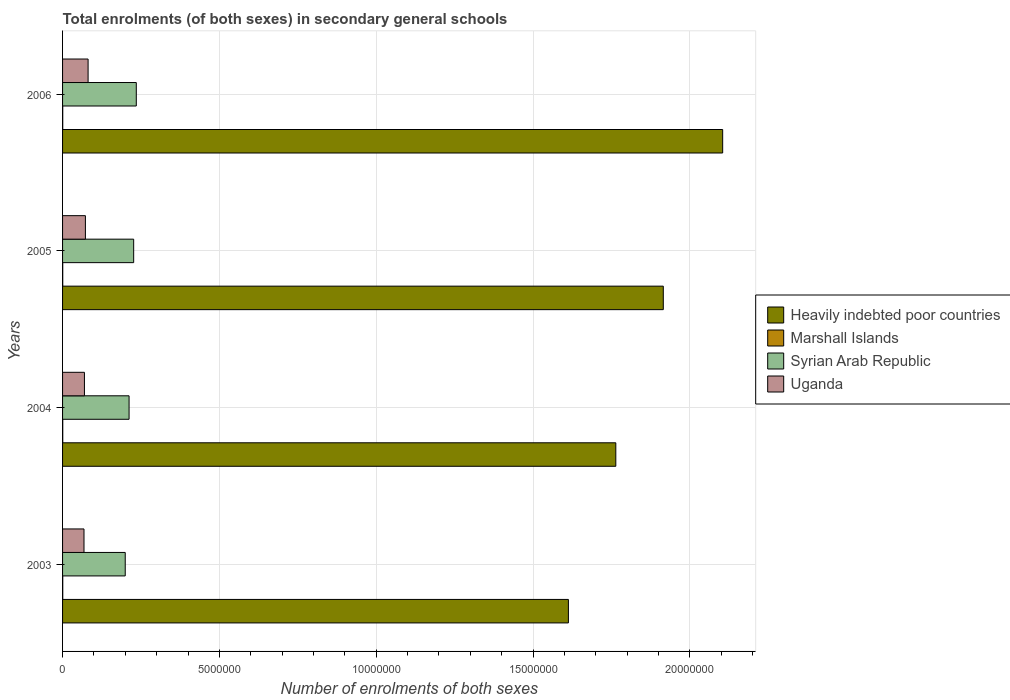Are the number of bars on each tick of the Y-axis equal?
Provide a short and direct response. Yes. How many bars are there on the 2nd tick from the top?
Give a very brief answer. 4. How many bars are there on the 1st tick from the bottom?
Make the answer very short. 4. What is the number of enrolments in secondary schools in Uganda in 2003?
Provide a succinct answer. 6.84e+05. Across all years, what is the maximum number of enrolments in secondary schools in Uganda?
Your response must be concise. 8.14e+05. Across all years, what is the minimum number of enrolments in secondary schools in Marshall Islands?
Your response must be concise. 5260. In which year was the number of enrolments in secondary schools in Syrian Arab Republic minimum?
Your answer should be compact. 2003. What is the total number of enrolments in secondary schools in Marshall Islands in the graph?
Give a very brief answer. 2.23e+04. What is the difference between the number of enrolments in secondary schools in Marshall Islands in 2004 and that in 2006?
Provide a succinct answer. 477. What is the difference between the number of enrolments in secondary schools in Uganda in 2006 and the number of enrolments in secondary schools in Marshall Islands in 2005?
Your answer should be very brief. 8.09e+05. What is the average number of enrolments in secondary schools in Uganda per year?
Your answer should be compact. 7.31e+05. In the year 2005, what is the difference between the number of enrolments in secondary schools in Marshall Islands and number of enrolments in secondary schools in Uganda?
Give a very brief answer. -7.23e+05. In how many years, is the number of enrolments in secondary schools in Uganda greater than 20000000 ?
Provide a short and direct response. 0. What is the ratio of the number of enrolments in secondary schools in Marshall Islands in 2004 to that in 2006?
Provide a succinct answer. 1.09. Is the number of enrolments in secondary schools in Syrian Arab Republic in 2003 less than that in 2005?
Give a very brief answer. Yes. Is the difference between the number of enrolments in secondary schools in Marshall Islands in 2003 and 2004 greater than the difference between the number of enrolments in secondary schools in Uganda in 2003 and 2004?
Offer a very short reply. Yes. What is the difference between the highest and the second highest number of enrolments in secondary schools in Heavily indebted poor countries?
Give a very brief answer. 1.89e+06. What is the difference between the highest and the lowest number of enrolments in secondary schools in Uganda?
Make the answer very short. 1.30e+05. In how many years, is the number of enrolments in secondary schools in Uganda greater than the average number of enrolments in secondary schools in Uganda taken over all years?
Keep it short and to the point. 1. Is it the case that in every year, the sum of the number of enrolments in secondary schools in Syrian Arab Republic and number of enrolments in secondary schools in Marshall Islands is greater than the sum of number of enrolments in secondary schools in Uganda and number of enrolments in secondary schools in Heavily indebted poor countries?
Keep it short and to the point. Yes. What does the 3rd bar from the top in 2003 represents?
Your answer should be very brief. Marshall Islands. What does the 3rd bar from the bottom in 2004 represents?
Your answer should be very brief. Syrian Arab Republic. Are all the bars in the graph horizontal?
Your answer should be compact. Yes. What is the difference between two consecutive major ticks on the X-axis?
Offer a very short reply. 5.00e+06. How many legend labels are there?
Your answer should be very brief. 4. What is the title of the graph?
Provide a succinct answer. Total enrolments (of both sexes) in secondary general schools. Does "Tajikistan" appear as one of the legend labels in the graph?
Offer a terse response. No. What is the label or title of the X-axis?
Your answer should be compact. Number of enrolments of both sexes. What is the label or title of the Y-axis?
Ensure brevity in your answer.  Years. What is the Number of enrolments of both sexes of Heavily indebted poor countries in 2003?
Your answer should be very brief. 1.61e+07. What is the Number of enrolments of both sexes in Marshall Islands in 2003?
Ensure brevity in your answer.  5781. What is the Number of enrolments of both sexes of Syrian Arab Republic in 2003?
Your answer should be compact. 2.00e+06. What is the Number of enrolments of both sexes in Uganda in 2003?
Ensure brevity in your answer.  6.84e+05. What is the Number of enrolments of both sexes in Heavily indebted poor countries in 2004?
Offer a terse response. 1.76e+07. What is the Number of enrolments of both sexes in Marshall Islands in 2004?
Your answer should be compact. 5846. What is the Number of enrolments of both sexes in Syrian Arab Republic in 2004?
Your answer should be compact. 2.12e+06. What is the Number of enrolments of both sexes in Uganda in 2004?
Keep it short and to the point. 6.98e+05. What is the Number of enrolments of both sexes in Heavily indebted poor countries in 2005?
Ensure brevity in your answer.  1.92e+07. What is the Number of enrolments of both sexes in Marshall Islands in 2005?
Provide a succinct answer. 5260. What is the Number of enrolments of both sexes in Syrian Arab Republic in 2005?
Provide a short and direct response. 2.27e+06. What is the Number of enrolments of both sexes of Uganda in 2005?
Provide a succinct answer. 7.28e+05. What is the Number of enrolments of both sexes of Heavily indebted poor countries in 2006?
Make the answer very short. 2.10e+07. What is the Number of enrolments of both sexes in Marshall Islands in 2006?
Your response must be concise. 5369. What is the Number of enrolments of both sexes of Syrian Arab Republic in 2006?
Give a very brief answer. 2.35e+06. What is the Number of enrolments of both sexes of Uganda in 2006?
Give a very brief answer. 8.14e+05. Across all years, what is the maximum Number of enrolments of both sexes in Heavily indebted poor countries?
Keep it short and to the point. 2.10e+07. Across all years, what is the maximum Number of enrolments of both sexes of Marshall Islands?
Your response must be concise. 5846. Across all years, what is the maximum Number of enrolments of both sexes in Syrian Arab Republic?
Your answer should be compact. 2.35e+06. Across all years, what is the maximum Number of enrolments of both sexes in Uganda?
Make the answer very short. 8.14e+05. Across all years, what is the minimum Number of enrolments of both sexes of Heavily indebted poor countries?
Give a very brief answer. 1.61e+07. Across all years, what is the minimum Number of enrolments of both sexes in Marshall Islands?
Offer a terse response. 5260. Across all years, what is the minimum Number of enrolments of both sexes in Syrian Arab Republic?
Keep it short and to the point. 2.00e+06. Across all years, what is the minimum Number of enrolments of both sexes of Uganda?
Your answer should be compact. 6.84e+05. What is the total Number of enrolments of both sexes of Heavily indebted poor countries in the graph?
Make the answer very short. 7.40e+07. What is the total Number of enrolments of both sexes of Marshall Islands in the graph?
Offer a terse response. 2.23e+04. What is the total Number of enrolments of both sexes in Syrian Arab Republic in the graph?
Your answer should be compact. 8.74e+06. What is the total Number of enrolments of both sexes in Uganda in the graph?
Your answer should be compact. 2.92e+06. What is the difference between the Number of enrolments of both sexes of Heavily indebted poor countries in 2003 and that in 2004?
Offer a terse response. -1.51e+06. What is the difference between the Number of enrolments of both sexes of Marshall Islands in 2003 and that in 2004?
Ensure brevity in your answer.  -65. What is the difference between the Number of enrolments of both sexes in Syrian Arab Republic in 2003 and that in 2004?
Provide a succinct answer. -1.23e+05. What is the difference between the Number of enrolments of both sexes of Uganda in 2003 and that in 2004?
Your answer should be compact. -1.39e+04. What is the difference between the Number of enrolments of both sexes of Heavily indebted poor countries in 2003 and that in 2005?
Provide a succinct answer. -3.03e+06. What is the difference between the Number of enrolments of both sexes of Marshall Islands in 2003 and that in 2005?
Ensure brevity in your answer.  521. What is the difference between the Number of enrolments of both sexes of Syrian Arab Republic in 2003 and that in 2005?
Keep it short and to the point. -2.69e+05. What is the difference between the Number of enrolments of both sexes of Uganda in 2003 and that in 2005?
Your answer should be compact. -4.48e+04. What is the difference between the Number of enrolments of both sexes of Heavily indebted poor countries in 2003 and that in 2006?
Your response must be concise. -4.92e+06. What is the difference between the Number of enrolments of both sexes of Marshall Islands in 2003 and that in 2006?
Your answer should be compact. 412. What is the difference between the Number of enrolments of both sexes in Syrian Arab Republic in 2003 and that in 2006?
Provide a succinct answer. -3.53e+05. What is the difference between the Number of enrolments of both sexes in Uganda in 2003 and that in 2006?
Offer a very short reply. -1.30e+05. What is the difference between the Number of enrolments of both sexes of Heavily indebted poor countries in 2004 and that in 2005?
Keep it short and to the point. -1.51e+06. What is the difference between the Number of enrolments of both sexes in Marshall Islands in 2004 and that in 2005?
Provide a short and direct response. 586. What is the difference between the Number of enrolments of both sexes in Syrian Arab Republic in 2004 and that in 2005?
Ensure brevity in your answer.  -1.46e+05. What is the difference between the Number of enrolments of both sexes in Uganda in 2004 and that in 2005?
Your response must be concise. -3.09e+04. What is the difference between the Number of enrolments of both sexes in Heavily indebted poor countries in 2004 and that in 2006?
Ensure brevity in your answer.  -3.41e+06. What is the difference between the Number of enrolments of both sexes in Marshall Islands in 2004 and that in 2006?
Offer a terse response. 477. What is the difference between the Number of enrolments of both sexes in Syrian Arab Republic in 2004 and that in 2006?
Offer a very short reply. -2.30e+05. What is the difference between the Number of enrolments of both sexes of Uganda in 2004 and that in 2006?
Your response must be concise. -1.17e+05. What is the difference between the Number of enrolments of both sexes of Heavily indebted poor countries in 2005 and that in 2006?
Ensure brevity in your answer.  -1.89e+06. What is the difference between the Number of enrolments of both sexes of Marshall Islands in 2005 and that in 2006?
Your answer should be very brief. -109. What is the difference between the Number of enrolments of both sexes of Syrian Arab Republic in 2005 and that in 2006?
Make the answer very short. -8.37e+04. What is the difference between the Number of enrolments of both sexes in Uganda in 2005 and that in 2006?
Give a very brief answer. -8.57e+04. What is the difference between the Number of enrolments of both sexes of Heavily indebted poor countries in 2003 and the Number of enrolments of both sexes of Marshall Islands in 2004?
Offer a terse response. 1.61e+07. What is the difference between the Number of enrolments of both sexes of Heavily indebted poor countries in 2003 and the Number of enrolments of both sexes of Syrian Arab Republic in 2004?
Offer a terse response. 1.40e+07. What is the difference between the Number of enrolments of both sexes in Heavily indebted poor countries in 2003 and the Number of enrolments of both sexes in Uganda in 2004?
Ensure brevity in your answer.  1.54e+07. What is the difference between the Number of enrolments of both sexes in Marshall Islands in 2003 and the Number of enrolments of both sexes in Syrian Arab Republic in 2004?
Ensure brevity in your answer.  -2.11e+06. What is the difference between the Number of enrolments of both sexes of Marshall Islands in 2003 and the Number of enrolments of both sexes of Uganda in 2004?
Provide a short and direct response. -6.92e+05. What is the difference between the Number of enrolments of both sexes of Syrian Arab Republic in 2003 and the Number of enrolments of both sexes of Uganda in 2004?
Your response must be concise. 1.30e+06. What is the difference between the Number of enrolments of both sexes of Heavily indebted poor countries in 2003 and the Number of enrolments of both sexes of Marshall Islands in 2005?
Provide a succinct answer. 1.61e+07. What is the difference between the Number of enrolments of both sexes of Heavily indebted poor countries in 2003 and the Number of enrolments of both sexes of Syrian Arab Republic in 2005?
Your answer should be compact. 1.39e+07. What is the difference between the Number of enrolments of both sexes of Heavily indebted poor countries in 2003 and the Number of enrolments of both sexes of Uganda in 2005?
Your answer should be compact. 1.54e+07. What is the difference between the Number of enrolments of both sexes in Marshall Islands in 2003 and the Number of enrolments of both sexes in Syrian Arab Republic in 2005?
Offer a terse response. -2.26e+06. What is the difference between the Number of enrolments of both sexes of Marshall Islands in 2003 and the Number of enrolments of both sexes of Uganda in 2005?
Offer a terse response. -7.23e+05. What is the difference between the Number of enrolments of both sexes in Syrian Arab Republic in 2003 and the Number of enrolments of both sexes in Uganda in 2005?
Keep it short and to the point. 1.27e+06. What is the difference between the Number of enrolments of both sexes of Heavily indebted poor countries in 2003 and the Number of enrolments of both sexes of Marshall Islands in 2006?
Provide a succinct answer. 1.61e+07. What is the difference between the Number of enrolments of both sexes in Heavily indebted poor countries in 2003 and the Number of enrolments of both sexes in Syrian Arab Republic in 2006?
Provide a short and direct response. 1.38e+07. What is the difference between the Number of enrolments of both sexes in Heavily indebted poor countries in 2003 and the Number of enrolments of both sexes in Uganda in 2006?
Keep it short and to the point. 1.53e+07. What is the difference between the Number of enrolments of both sexes of Marshall Islands in 2003 and the Number of enrolments of both sexes of Syrian Arab Republic in 2006?
Your answer should be compact. -2.34e+06. What is the difference between the Number of enrolments of both sexes in Marshall Islands in 2003 and the Number of enrolments of both sexes in Uganda in 2006?
Keep it short and to the point. -8.08e+05. What is the difference between the Number of enrolments of both sexes in Syrian Arab Republic in 2003 and the Number of enrolments of both sexes in Uganda in 2006?
Give a very brief answer. 1.18e+06. What is the difference between the Number of enrolments of both sexes of Heavily indebted poor countries in 2004 and the Number of enrolments of both sexes of Marshall Islands in 2005?
Keep it short and to the point. 1.76e+07. What is the difference between the Number of enrolments of both sexes in Heavily indebted poor countries in 2004 and the Number of enrolments of both sexes in Syrian Arab Republic in 2005?
Offer a terse response. 1.54e+07. What is the difference between the Number of enrolments of both sexes in Heavily indebted poor countries in 2004 and the Number of enrolments of both sexes in Uganda in 2005?
Make the answer very short. 1.69e+07. What is the difference between the Number of enrolments of both sexes in Marshall Islands in 2004 and the Number of enrolments of both sexes in Syrian Arab Republic in 2005?
Make the answer very short. -2.26e+06. What is the difference between the Number of enrolments of both sexes of Marshall Islands in 2004 and the Number of enrolments of both sexes of Uganda in 2005?
Your response must be concise. -7.23e+05. What is the difference between the Number of enrolments of both sexes in Syrian Arab Republic in 2004 and the Number of enrolments of both sexes in Uganda in 2005?
Offer a terse response. 1.39e+06. What is the difference between the Number of enrolments of both sexes in Heavily indebted poor countries in 2004 and the Number of enrolments of both sexes in Marshall Islands in 2006?
Provide a succinct answer. 1.76e+07. What is the difference between the Number of enrolments of both sexes in Heavily indebted poor countries in 2004 and the Number of enrolments of both sexes in Syrian Arab Republic in 2006?
Offer a terse response. 1.53e+07. What is the difference between the Number of enrolments of both sexes in Heavily indebted poor countries in 2004 and the Number of enrolments of both sexes in Uganda in 2006?
Offer a very short reply. 1.68e+07. What is the difference between the Number of enrolments of both sexes of Marshall Islands in 2004 and the Number of enrolments of both sexes of Syrian Arab Republic in 2006?
Offer a terse response. -2.34e+06. What is the difference between the Number of enrolments of both sexes of Marshall Islands in 2004 and the Number of enrolments of both sexes of Uganda in 2006?
Provide a succinct answer. -8.08e+05. What is the difference between the Number of enrolments of both sexes of Syrian Arab Republic in 2004 and the Number of enrolments of both sexes of Uganda in 2006?
Make the answer very short. 1.31e+06. What is the difference between the Number of enrolments of both sexes in Heavily indebted poor countries in 2005 and the Number of enrolments of both sexes in Marshall Islands in 2006?
Make the answer very short. 1.91e+07. What is the difference between the Number of enrolments of both sexes of Heavily indebted poor countries in 2005 and the Number of enrolments of both sexes of Syrian Arab Republic in 2006?
Make the answer very short. 1.68e+07. What is the difference between the Number of enrolments of both sexes of Heavily indebted poor countries in 2005 and the Number of enrolments of both sexes of Uganda in 2006?
Your answer should be compact. 1.83e+07. What is the difference between the Number of enrolments of both sexes in Marshall Islands in 2005 and the Number of enrolments of both sexes in Syrian Arab Republic in 2006?
Make the answer very short. -2.35e+06. What is the difference between the Number of enrolments of both sexes in Marshall Islands in 2005 and the Number of enrolments of both sexes in Uganda in 2006?
Your response must be concise. -8.09e+05. What is the difference between the Number of enrolments of both sexes of Syrian Arab Republic in 2005 and the Number of enrolments of both sexes of Uganda in 2006?
Give a very brief answer. 1.45e+06. What is the average Number of enrolments of both sexes of Heavily indebted poor countries per year?
Provide a succinct answer. 1.85e+07. What is the average Number of enrolments of both sexes of Marshall Islands per year?
Give a very brief answer. 5564. What is the average Number of enrolments of both sexes of Syrian Arab Republic per year?
Your answer should be compact. 2.18e+06. What is the average Number of enrolments of both sexes in Uganda per year?
Your answer should be compact. 7.31e+05. In the year 2003, what is the difference between the Number of enrolments of both sexes in Heavily indebted poor countries and Number of enrolments of both sexes in Marshall Islands?
Your response must be concise. 1.61e+07. In the year 2003, what is the difference between the Number of enrolments of both sexes in Heavily indebted poor countries and Number of enrolments of both sexes in Syrian Arab Republic?
Your response must be concise. 1.41e+07. In the year 2003, what is the difference between the Number of enrolments of both sexes in Heavily indebted poor countries and Number of enrolments of both sexes in Uganda?
Offer a terse response. 1.54e+07. In the year 2003, what is the difference between the Number of enrolments of both sexes in Marshall Islands and Number of enrolments of both sexes in Syrian Arab Republic?
Give a very brief answer. -1.99e+06. In the year 2003, what is the difference between the Number of enrolments of both sexes in Marshall Islands and Number of enrolments of both sexes in Uganda?
Make the answer very short. -6.78e+05. In the year 2003, what is the difference between the Number of enrolments of both sexes in Syrian Arab Republic and Number of enrolments of both sexes in Uganda?
Keep it short and to the point. 1.31e+06. In the year 2004, what is the difference between the Number of enrolments of both sexes in Heavily indebted poor countries and Number of enrolments of both sexes in Marshall Islands?
Ensure brevity in your answer.  1.76e+07. In the year 2004, what is the difference between the Number of enrolments of both sexes of Heavily indebted poor countries and Number of enrolments of both sexes of Syrian Arab Republic?
Give a very brief answer. 1.55e+07. In the year 2004, what is the difference between the Number of enrolments of both sexes in Heavily indebted poor countries and Number of enrolments of both sexes in Uganda?
Your answer should be very brief. 1.69e+07. In the year 2004, what is the difference between the Number of enrolments of both sexes in Marshall Islands and Number of enrolments of both sexes in Syrian Arab Republic?
Ensure brevity in your answer.  -2.11e+06. In the year 2004, what is the difference between the Number of enrolments of both sexes in Marshall Islands and Number of enrolments of both sexes in Uganda?
Ensure brevity in your answer.  -6.92e+05. In the year 2004, what is the difference between the Number of enrolments of both sexes in Syrian Arab Republic and Number of enrolments of both sexes in Uganda?
Provide a succinct answer. 1.42e+06. In the year 2005, what is the difference between the Number of enrolments of both sexes of Heavily indebted poor countries and Number of enrolments of both sexes of Marshall Islands?
Keep it short and to the point. 1.91e+07. In the year 2005, what is the difference between the Number of enrolments of both sexes of Heavily indebted poor countries and Number of enrolments of both sexes of Syrian Arab Republic?
Ensure brevity in your answer.  1.69e+07. In the year 2005, what is the difference between the Number of enrolments of both sexes of Heavily indebted poor countries and Number of enrolments of both sexes of Uganda?
Offer a very short reply. 1.84e+07. In the year 2005, what is the difference between the Number of enrolments of both sexes in Marshall Islands and Number of enrolments of both sexes in Syrian Arab Republic?
Your response must be concise. -2.26e+06. In the year 2005, what is the difference between the Number of enrolments of both sexes in Marshall Islands and Number of enrolments of both sexes in Uganda?
Give a very brief answer. -7.23e+05. In the year 2005, what is the difference between the Number of enrolments of both sexes in Syrian Arab Republic and Number of enrolments of both sexes in Uganda?
Your response must be concise. 1.54e+06. In the year 2006, what is the difference between the Number of enrolments of both sexes of Heavily indebted poor countries and Number of enrolments of both sexes of Marshall Islands?
Make the answer very short. 2.10e+07. In the year 2006, what is the difference between the Number of enrolments of both sexes in Heavily indebted poor countries and Number of enrolments of both sexes in Syrian Arab Republic?
Offer a very short reply. 1.87e+07. In the year 2006, what is the difference between the Number of enrolments of both sexes in Heavily indebted poor countries and Number of enrolments of both sexes in Uganda?
Your response must be concise. 2.02e+07. In the year 2006, what is the difference between the Number of enrolments of both sexes in Marshall Islands and Number of enrolments of both sexes in Syrian Arab Republic?
Provide a short and direct response. -2.35e+06. In the year 2006, what is the difference between the Number of enrolments of both sexes in Marshall Islands and Number of enrolments of both sexes in Uganda?
Offer a terse response. -8.09e+05. In the year 2006, what is the difference between the Number of enrolments of both sexes in Syrian Arab Republic and Number of enrolments of both sexes in Uganda?
Your answer should be compact. 1.54e+06. What is the ratio of the Number of enrolments of both sexes in Heavily indebted poor countries in 2003 to that in 2004?
Give a very brief answer. 0.91. What is the ratio of the Number of enrolments of both sexes in Marshall Islands in 2003 to that in 2004?
Keep it short and to the point. 0.99. What is the ratio of the Number of enrolments of both sexes of Syrian Arab Republic in 2003 to that in 2004?
Your answer should be very brief. 0.94. What is the ratio of the Number of enrolments of both sexes in Uganda in 2003 to that in 2004?
Offer a very short reply. 0.98. What is the ratio of the Number of enrolments of both sexes of Heavily indebted poor countries in 2003 to that in 2005?
Give a very brief answer. 0.84. What is the ratio of the Number of enrolments of both sexes of Marshall Islands in 2003 to that in 2005?
Provide a short and direct response. 1.1. What is the ratio of the Number of enrolments of both sexes in Syrian Arab Republic in 2003 to that in 2005?
Ensure brevity in your answer.  0.88. What is the ratio of the Number of enrolments of both sexes of Uganda in 2003 to that in 2005?
Offer a terse response. 0.94. What is the ratio of the Number of enrolments of both sexes in Heavily indebted poor countries in 2003 to that in 2006?
Give a very brief answer. 0.77. What is the ratio of the Number of enrolments of both sexes of Marshall Islands in 2003 to that in 2006?
Keep it short and to the point. 1.08. What is the ratio of the Number of enrolments of both sexes in Syrian Arab Republic in 2003 to that in 2006?
Your answer should be very brief. 0.85. What is the ratio of the Number of enrolments of both sexes of Uganda in 2003 to that in 2006?
Keep it short and to the point. 0.84. What is the ratio of the Number of enrolments of both sexes of Heavily indebted poor countries in 2004 to that in 2005?
Offer a very short reply. 0.92. What is the ratio of the Number of enrolments of both sexes of Marshall Islands in 2004 to that in 2005?
Keep it short and to the point. 1.11. What is the ratio of the Number of enrolments of both sexes of Syrian Arab Republic in 2004 to that in 2005?
Offer a terse response. 0.94. What is the ratio of the Number of enrolments of both sexes in Uganda in 2004 to that in 2005?
Make the answer very short. 0.96. What is the ratio of the Number of enrolments of both sexes in Heavily indebted poor countries in 2004 to that in 2006?
Provide a short and direct response. 0.84. What is the ratio of the Number of enrolments of both sexes of Marshall Islands in 2004 to that in 2006?
Your answer should be very brief. 1.09. What is the ratio of the Number of enrolments of both sexes in Syrian Arab Republic in 2004 to that in 2006?
Make the answer very short. 0.9. What is the ratio of the Number of enrolments of both sexes of Uganda in 2004 to that in 2006?
Give a very brief answer. 0.86. What is the ratio of the Number of enrolments of both sexes of Heavily indebted poor countries in 2005 to that in 2006?
Your response must be concise. 0.91. What is the ratio of the Number of enrolments of both sexes of Marshall Islands in 2005 to that in 2006?
Provide a short and direct response. 0.98. What is the ratio of the Number of enrolments of both sexes of Syrian Arab Republic in 2005 to that in 2006?
Offer a terse response. 0.96. What is the ratio of the Number of enrolments of both sexes in Uganda in 2005 to that in 2006?
Provide a short and direct response. 0.89. What is the difference between the highest and the second highest Number of enrolments of both sexes of Heavily indebted poor countries?
Your answer should be compact. 1.89e+06. What is the difference between the highest and the second highest Number of enrolments of both sexes of Syrian Arab Republic?
Offer a very short reply. 8.37e+04. What is the difference between the highest and the second highest Number of enrolments of both sexes of Uganda?
Provide a short and direct response. 8.57e+04. What is the difference between the highest and the lowest Number of enrolments of both sexes in Heavily indebted poor countries?
Your response must be concise. 4.92e+06. What is the difference between the highest and the lowest Number of enrolments of both sexes of Marshall Islands?
Make the answer very short. 586. What is the difference between the highest and the lowest Number of enrolments of both sexes in Syrian Arab Republic?
Your response must be concise. 3.53e+05. What is the difference between the highest and the lowest Number of enrolments of both sexes of Uganda?
Provide a short and direct response. 1.30e+05. 